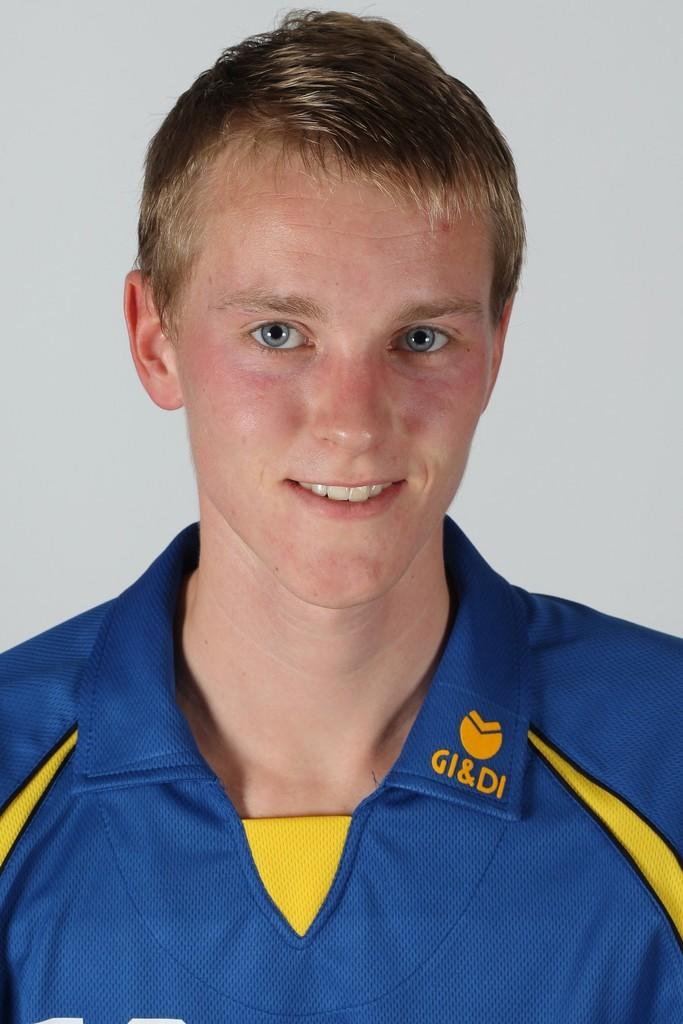<image>
Summarize the visual content of the image. A man is wearing a blue and yellow shirt that says GI&DI on the collar. 